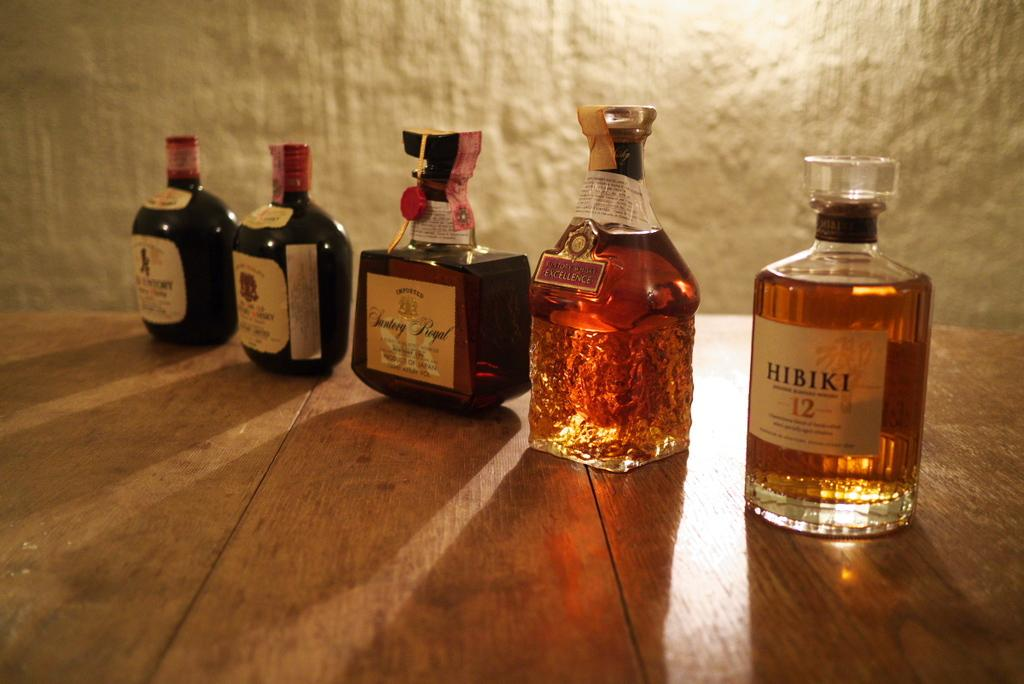<image>
Provide a brief description of the given image. the word Hibiki is on the glass item 